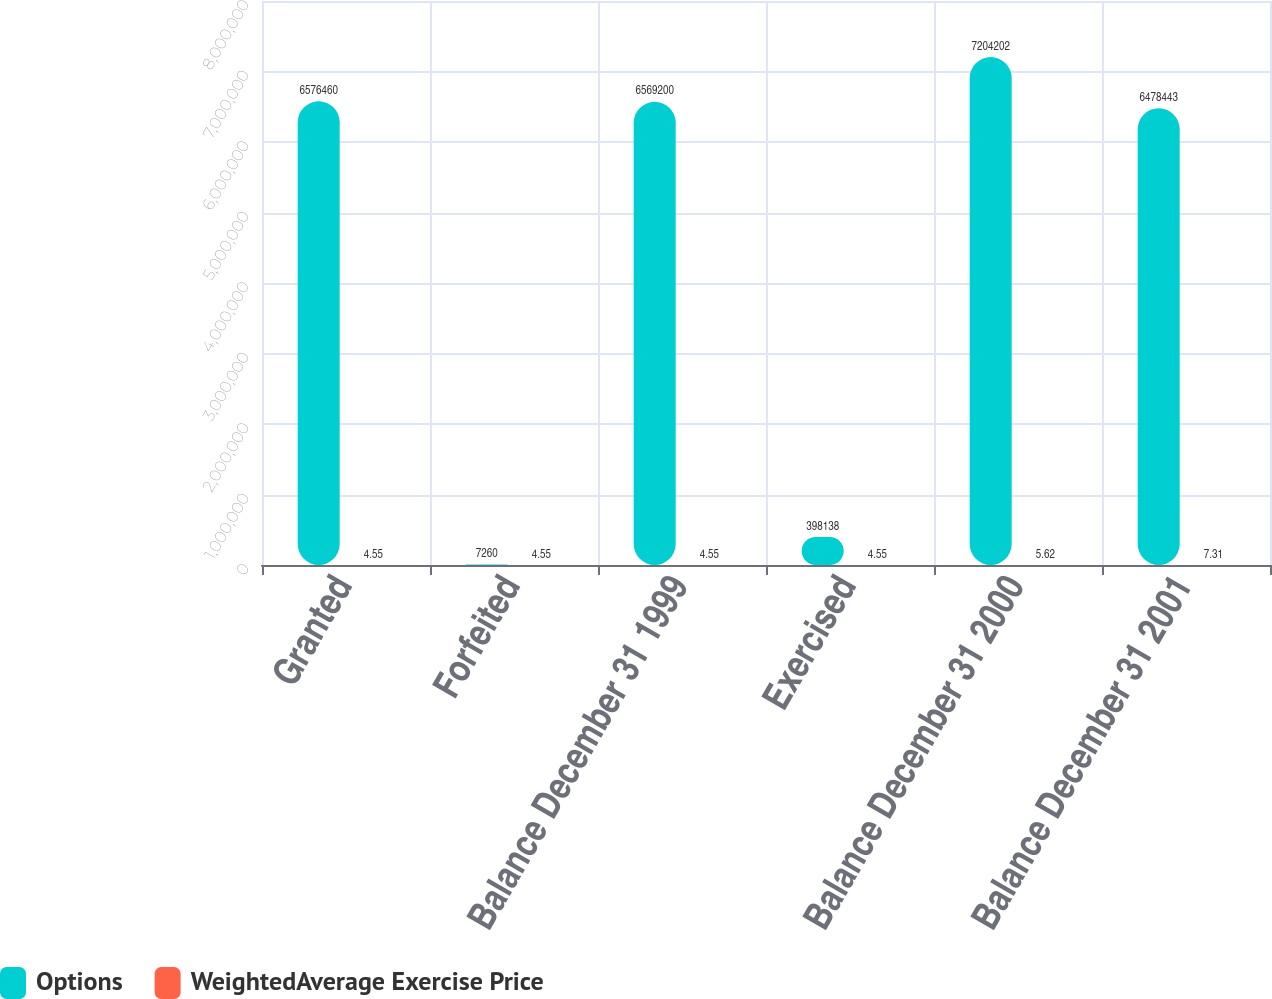<chart> <loc_0><loc_0><loc_500><loc_500><stacked_bar_chart><ecel><fcel>Granted<fcel>Forfeited<fcel>Balance December 31 1999<fcel>Exercised<fcel>Balance December 31 2000<fcel>Balance December 31 2001<nl><fcel>Options<fcel>6.57646e+06<fcel>7260<fcel>6.5692e+06<fcel>398138<fcel>7.2042e+06<fcel>6.47844e+06<nl><fcel>WeightedAverage Exercise Price<fcel>4.55<fcel>4.55<fcel>4.55<fcel>4.55<fcel>5.62<fcel>7.31<nl></chart> 